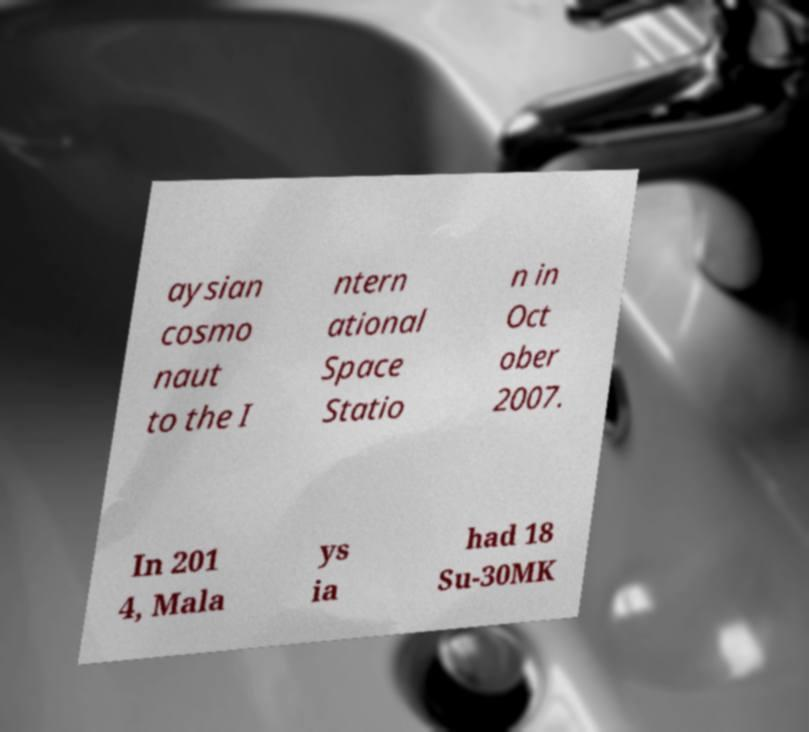Could you assist in decoding the text presented in this image and type it out clearly? aysian cosmo naut to the I ntern ational Space Statio n in Oct ober 2007. In 201 4, Mala ys ia had 18 Su-30MK 